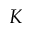<formula> <loc_0><loc_0><loc_500><loc_500>K</formula> 